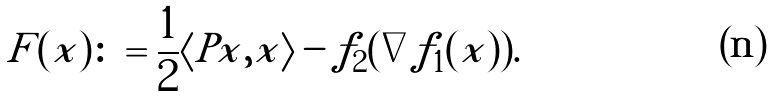<formula> <loc_0><loc_0><loc_500><loc_500>F ( x ) \colon = \frac { 1 } { 2 } \langle P x , x \rangle - f _ { 2 } ( \nabla f _ { 1 } ( x ) ) .</formula> 